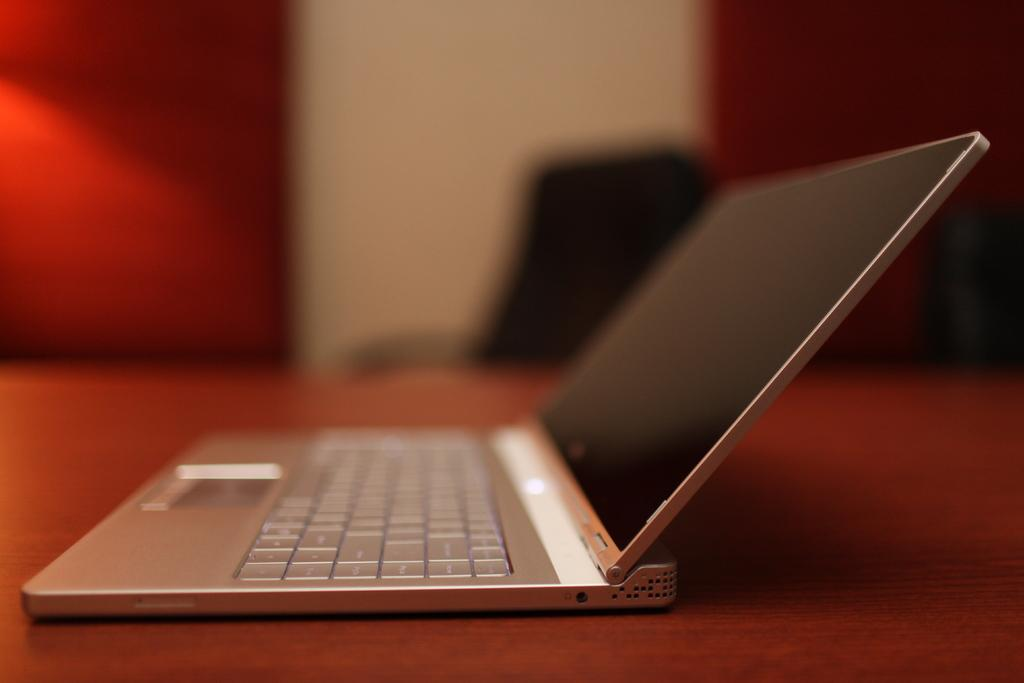What electronic device is visible in the image? There is a laptop in the image. What color is the surface on which the laptop is placed? The laptop is on a red-colored surface. Can you describe the background of the image? The background of the image is blurry. Where is the calendar placed in the image? There is no calendar present in the image. What type of stick can be seen in the image? There is no stick present in the image. 